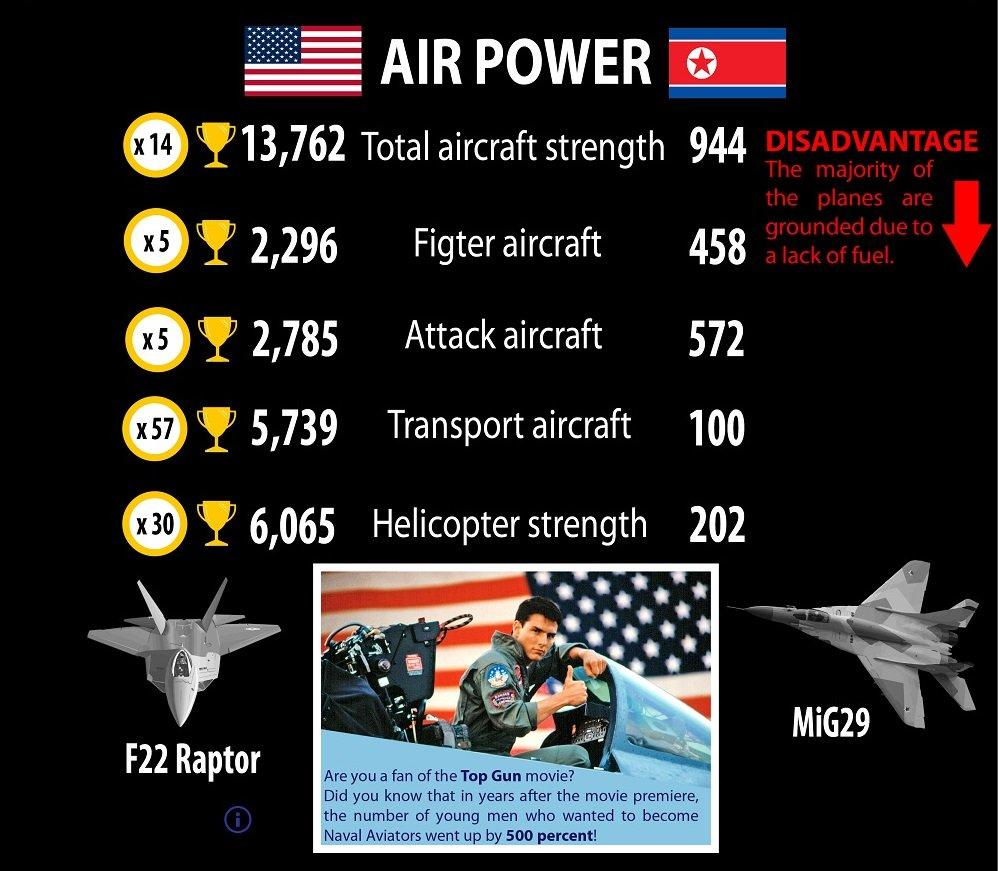Draw attention to some important aspects in this diagram. The United States has several major fighter aircrafts, including the F22 Raptor and MiG29. As of my knowledge cutoff in September 2021, there were 2 listed fighter aircrafts of America. 